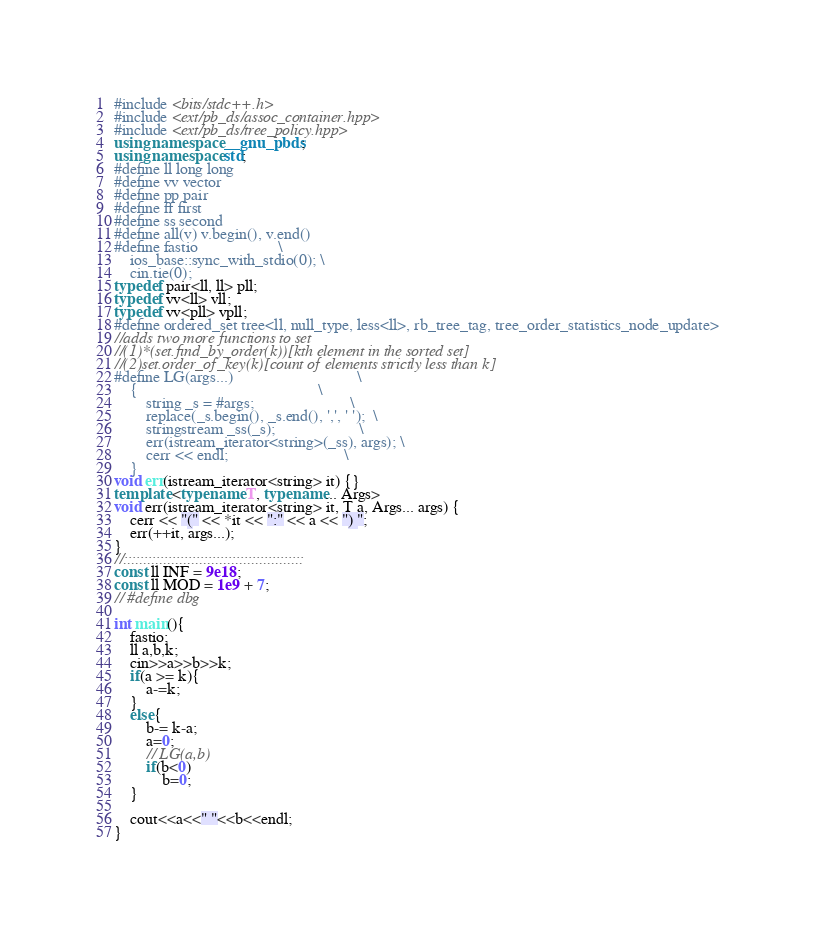<code> <loc_0><loc_0><loc_500><loc_500><_C++_>#include <bits/stdc++.h>
#include <ext/pb_ds/assoc_container.hpp>
#include <ext/pb_ds/tree_policy.hpp>
using namespace __gnu_pbds;
using namespace std;
#define ll long long
#define vv vector
#define pp pair
#define ff first
#define ss second
#define all(v) v.begin(), v.end()
#define fastio                    \
	ios_base::sync_with_stdio(0); \
	cin.tie(0);
typedef pair<ll, ll> pll;
typedef vv<ll> vll;
typedef vv<pll> vpll;
#define ordered_set tree<ll, null_type, less<ll>, rb_tree_tag, tree_order_statistics_node_update>
//adds two more functions to set
//(1)*(set.find_by_order(k))[kth element in the sorted set]
//(2)set.order_of_key(k)[count of elements strictly less than k]
#define LG(args...)                               \
	{                                             \
		string _s = #args;                        \
		replace(_s.begin(), _s.end(), ',', ' ');  \
		stringstream _ss(_s);                     \
		err(istream_iterator<string>(_ss), args); \
		cerr << endl;                             \
	}
void err(istream_iterator<string> it) {}
template <typename T, typename... Args>
void err(istream_iterator<string> it, T a, Args... args) {
	cerr << "(" << *it << ":" << a << ") ";
	err(++it, args...);
}
//:::::::::::::::::::::::::::::::::::::::::::::
const ll INF = 9e18;
const ll MOD = 1e9 + 7;
// #define dbg

int main(){
	fastio;
	ll a,b,k;
	cin>>a>>b>>k;
	if(a >= k){
		a-=k;
	}
	else{
		b-= k-a;
		a=0;
		// LG(a,b)
		if(b<0)
			b=0;
	}

	cout<<a<<" "<<b<<endl;
}</code> 